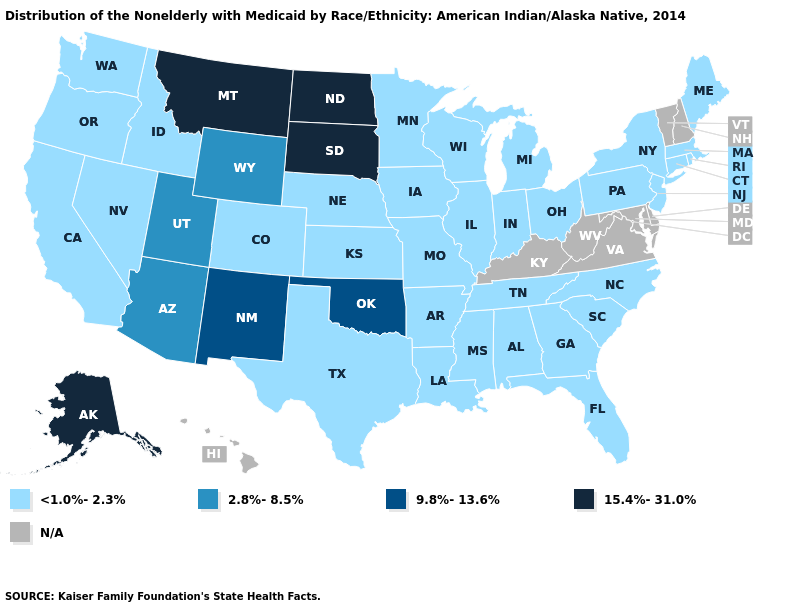Does Louisiana have the lowest value in the USA?
Be succinct. Yes. Name the states that have a value in the range N/A?
Write a very short answer. Delaware, Hawaii, Kentucky, Maryland, New Hampshire, Vermont, Virginia, West Virginia. Is the legend a continuous bar?
Write a very short answer. No. Which states have the lowest value in the Northeast?
Be succinct. Connecticut, Maine, Massachusetts, New Jersey, New York, Pennsylvania, Rhode Island. What is the highest value in states that border Washington?
Answer briefly. <1.0%-2.3%. What is the value of Illinois?
Answer briefly. <1.0%-2.3%. Name the states that have a value in the range 15.4%-31.0%?
Write a very short answer. Alaska, Montana, North Dakota, South Dakota. Which states have the lowest value in the West?
Write a very short answer. California, Colorado, Idaho, Nevada, Oregon, Washington. Name the states that have a value in the range 15.4%-31.0%?
Quick response, please. Alaska, Montana, North Dakota, South Dakota. What is the lowest value in states that border North Dakota?
Give a very brief answer. <1.0%-2.3%. How many symbols are there in the legend?
Write a very short answer. 5. What is the highest value in the USA?
Concise answer only. 15.4%-31.0%. 